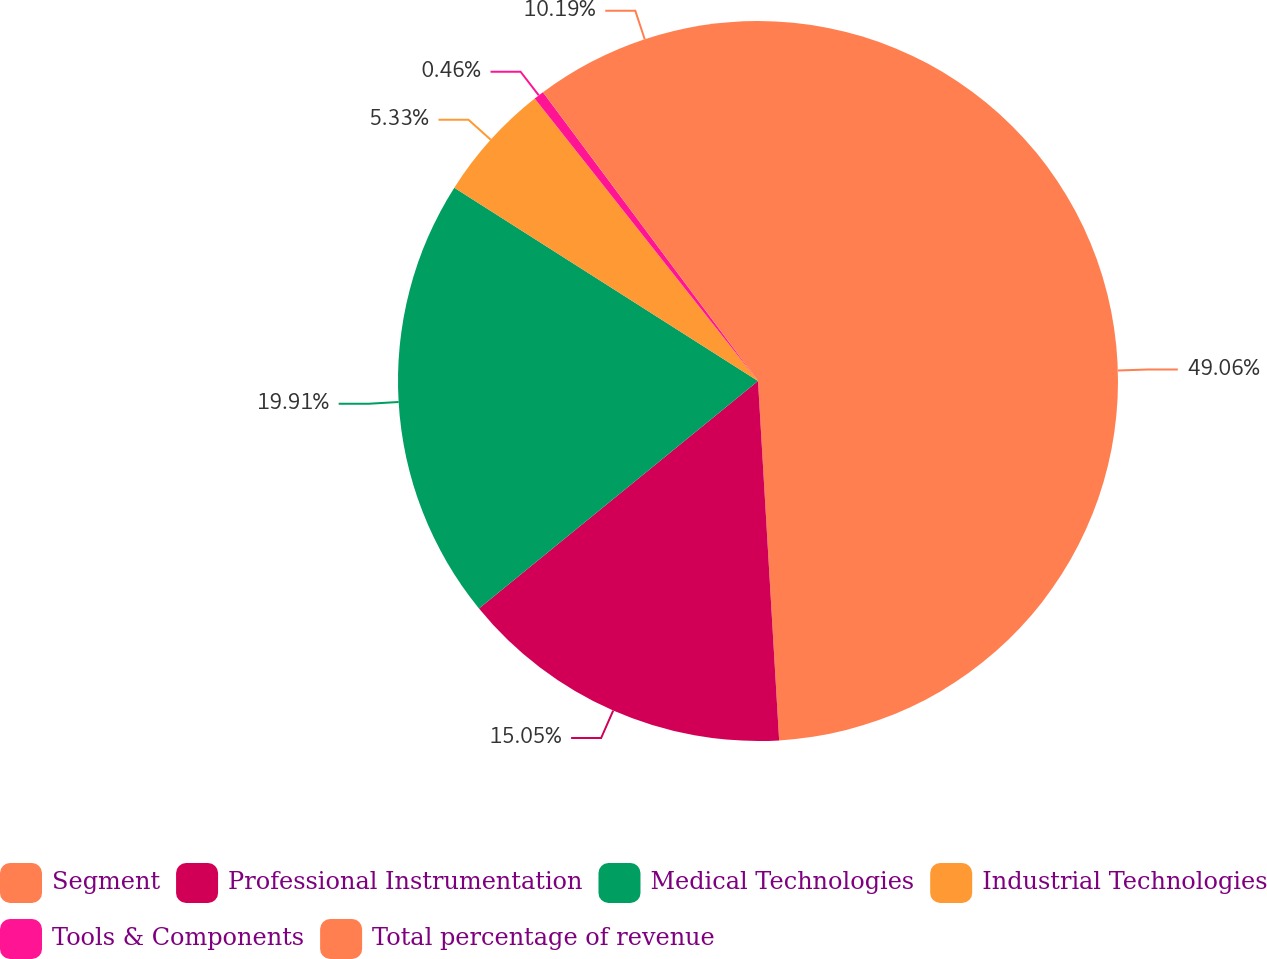<chart> <loc_0><loc_0><loc_500><loc_500><pie_chart><fcel>Segment<fcel>Professional Instrumentation<fcel>Medical Technologies<fcel>Industrial Technologies<fcel>Tools & Components<fcel>Total percentage of revenue<nl><fcel>49.07%<fcel>15.05%<fcel>19.91%<fcel>5.33%<fcel>0.46%<fcel>10.19%<nl></chart> 